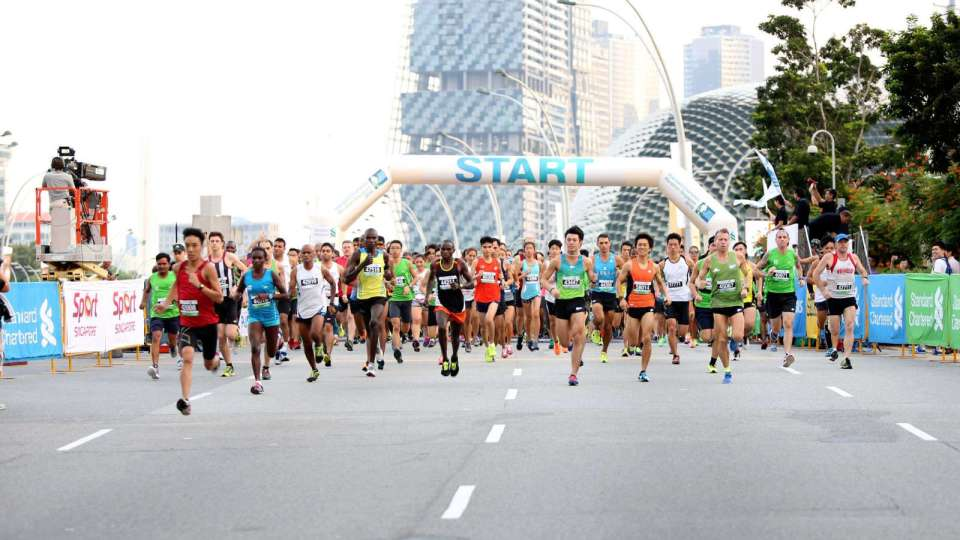Is there any indication of the location or specific event based on the surroundings or any visible signage? Based on the visible content in the image, there are limited explicit textual indications of the specific location or event. The runners' bibs and the 'START' banner do not present identifiable text regarding the location or event. However, the architectural features in the background and the presence of branded sponsorship banners (like 'Standard Chartered') might offer indirect hints but still require additional context for accurate identification. Hence, without further textual or contextual clues, determining the exact location or event from this image alone remains inconclusive. 